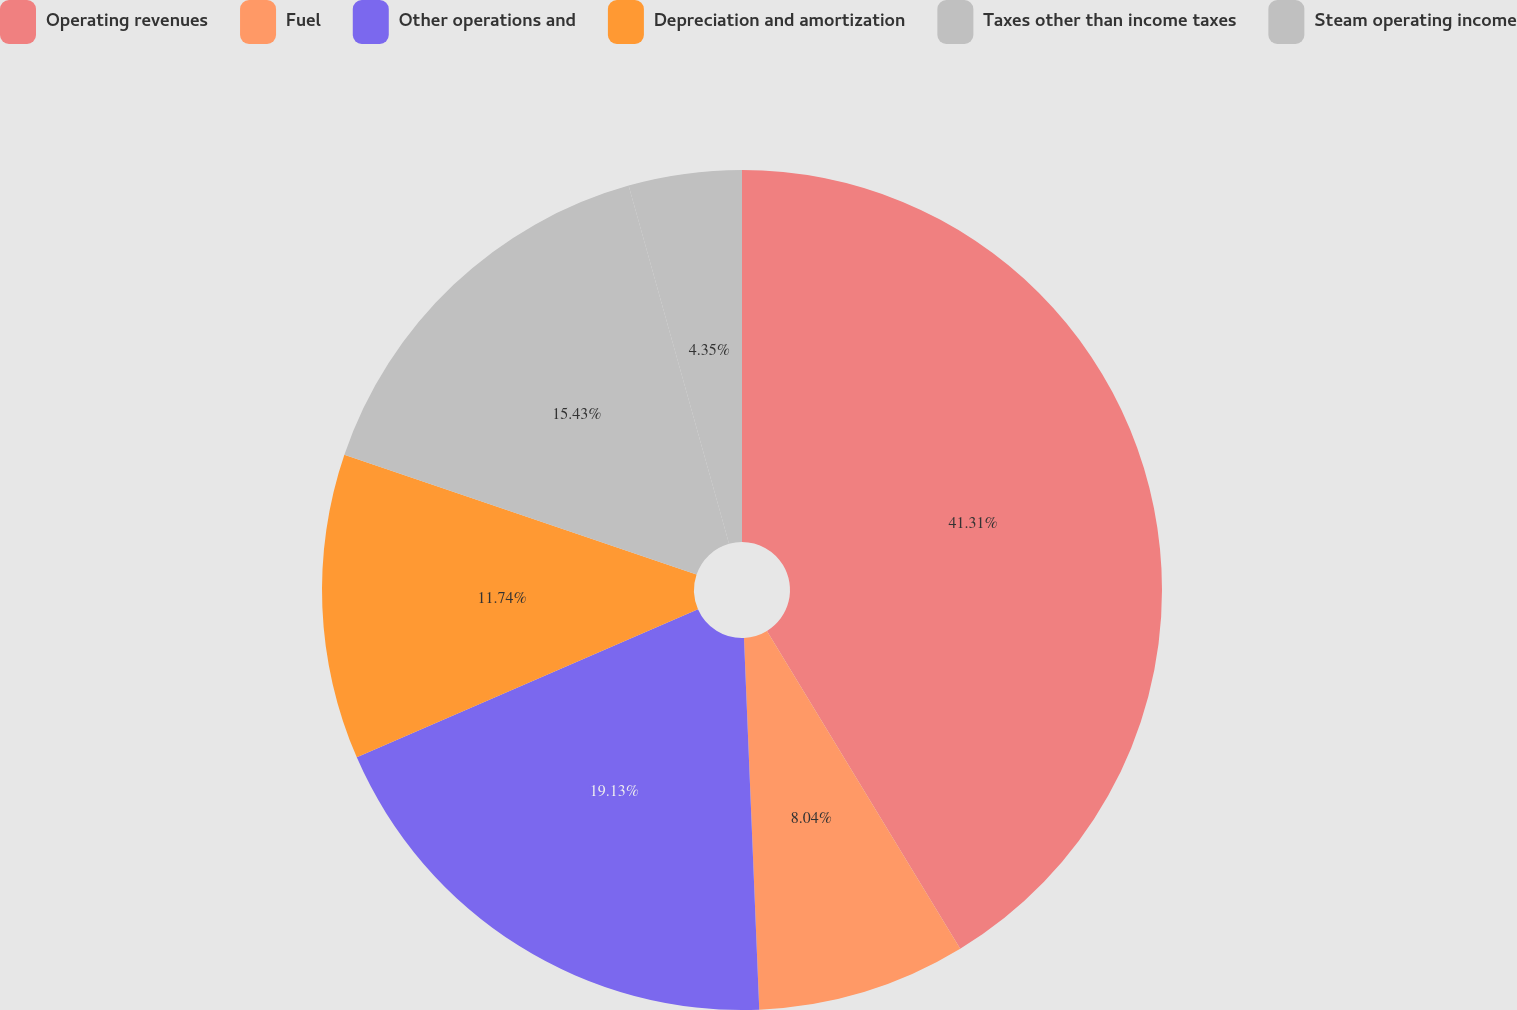Convert chart. <chart><loc_0><loc_0><loc_500><loc_500><pie_chart><fcel>Operating revenues<fcel>Fuel<fcel>Other operations and<fcel>Depreciation and amortization<fcel>Taxes other than income taxes<fcel>Steam operating income<nl><fcel>41.3%<fcel>8.04%<fcel>19.13%<fcel>11.74%<fcel>15.43%<fcel>4.35%<nl></chart> 